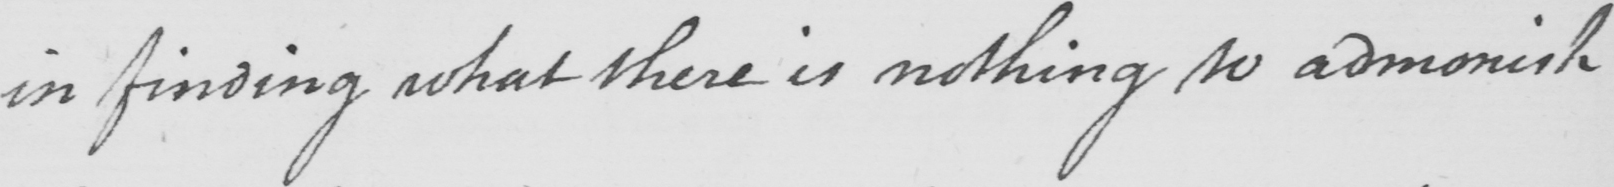What does this handwritten line say? in finding what there is nothing to admonish 